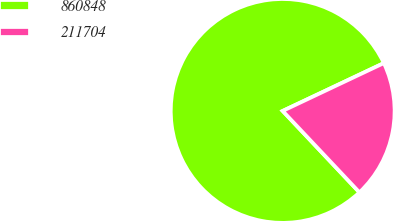Convert chart. <chart><loc_0><loc_0><loc_500><loc_500><pie_chart><fcel>860848<fcel>211704<nl><fcel>80.0%<fcel>20.0%<nl></chart> 